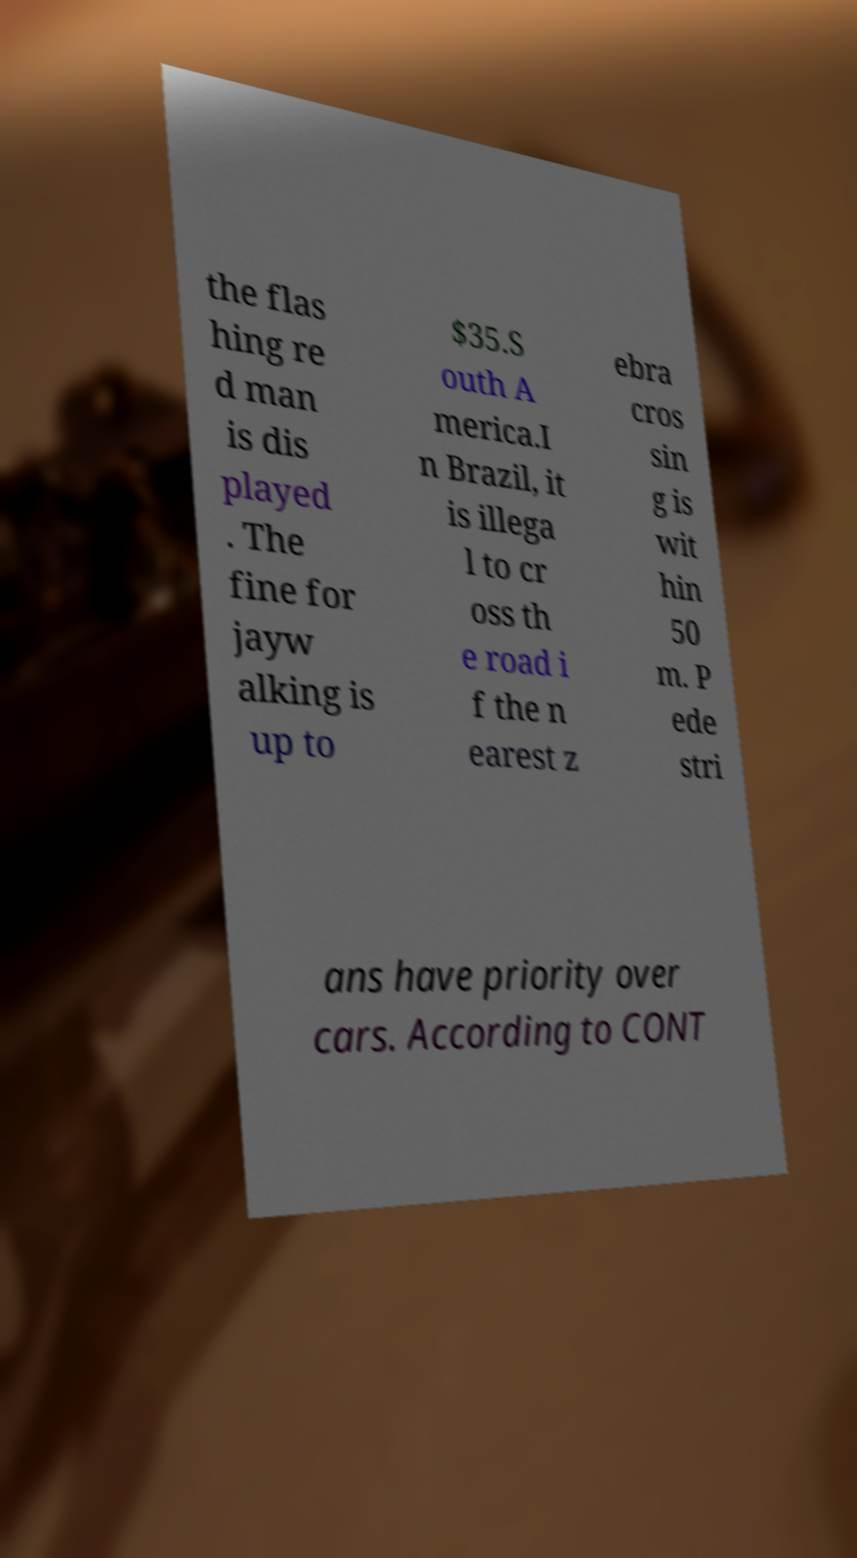For documentation purposes, I need the text within this image transcribed. Could you provide that? the flas hing re d man is dis played . The fine for jayw alking is up to $35.S outh A merica.I n Brazil, it is illega l to cr oss th e road i f the n earest z ebra cros sin g is wit hin 50 m. P ede stri ans have priority over cars. According to CONT 